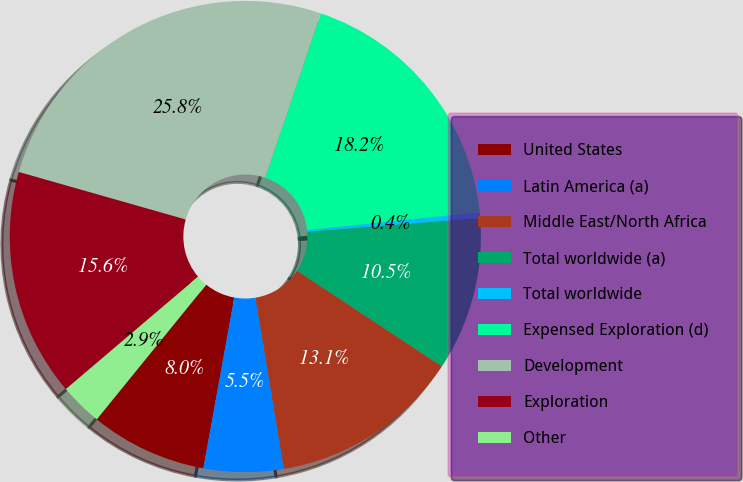Convert chart to OTSL. <chart><loc_0><loc_0><loc_500><loc_500><pie_chart><fcel>United States<fcel>Latin America (a)<fcel>Middle East/North Africa<fcel>Total worldwide (a)<fcel>Total worldwide<fcel>Expensed Exploration (d)<fcel>Development<fcel>Exploration<fcel>Other<nl><fcel>8.01%<fcel>5.47%<fcel>13.09%<fcel>10.55%<fcel>0.39%<fcel>18.17%<fcel>25.78%<fcel>15.63%<fcel>2.93%<nl></chart> 